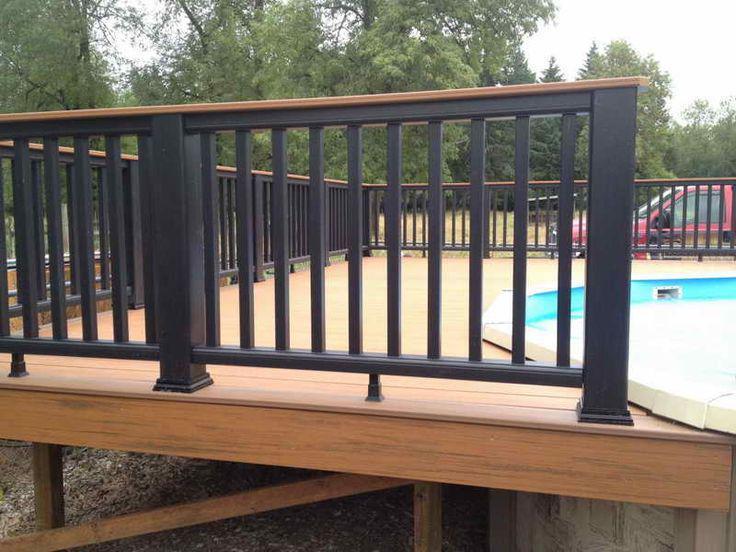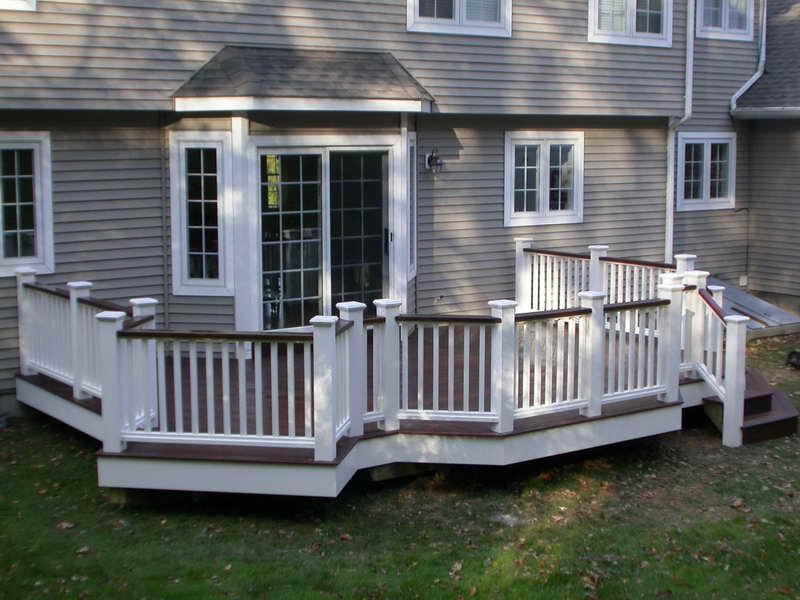The first image is the image on the left, the second image is the image on the right. Considering the images on both sides, is "One of the railings has white main posts with smaller black posts in between." valid? Answer yes or no. No. The first image is the image on the left, the second image is the image on the right. Evaluate the accuracy of this statement regarding the images: "The right image shows a deck with a jutting section instead of a straight across front, and white corner posts with dark brown flat boards atop the handrails.". Is it true? Answer yes or no. Yes. 